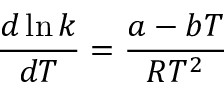<formula> <loc_0><loc_0><loc_500><loc_500>{ \frac { d \ln k } { d T } } = { \frac { a - b T } { R T ^ { 2 } } }</formula> 